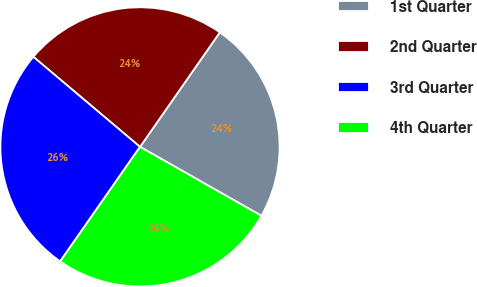Convert chart. <chart><loc_0><loc_0><loc_500><loc_500><pie_chart><fcel>1st Quarter<fcel>2nd Quarter<fcel>3rd Quarter<fcel>4th Quarter<nl><fcel>23.53%<fcel>23.53%<fcel>26.47%<fcel>26.47%<nl></chart> 